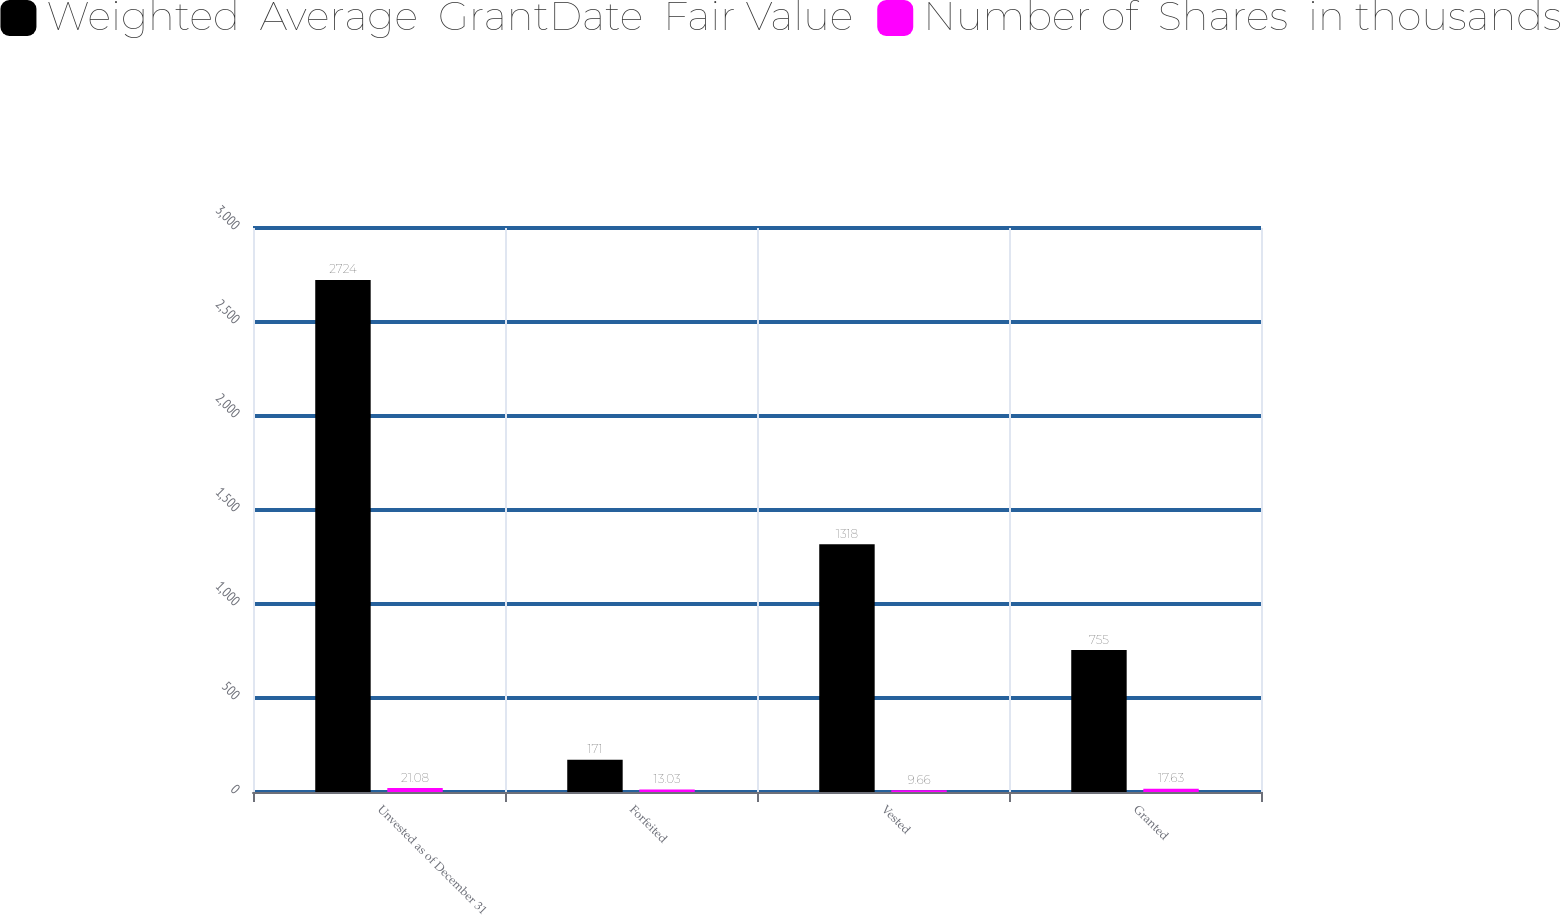Convert chart. <chart><loc_0><loc_0><loc_500><loc_500><stacked_bar_chart><ecel><fcel>Unvested as of December 31<fcel>Forfeited<fcel>Vested<fcel>Granted<nl><fcel>Weighted  Average  GrantDate  Fair Value<fcel>2724<fcel>171<fcel>1318<fcel>755<nl><fcel>Number of  Shares  in thousands<fcel>21.08<fcel>13.03<fcel>9.66<fcel>17.63<nl></chart> 